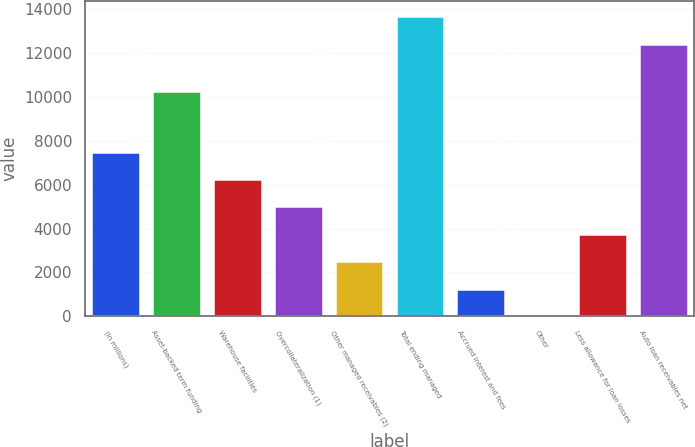Convert chart. <chart><loc_0><loc_0><loc_500><loc_500><bar_chart><fcel>(In millions)<fcel>Asset-backed term funding<fcel>Warehouse facilities<fcel>Overcollateralization (1)<fcel>Other managed receivables (2)<fcel>Total ending managed<fcel>Accrued interest and fees<fcel>Other<fcel>Less allowance for loan losses<fcel>Auto loan receivables net<nl><fcel>7508.88<fcel>10273.4<fcel>6258.55<fcel>5008.22<fcel>2507.56<fcel>13678.8<fcel>1257.23<fcel>6.9<fcel>3757.89<fcel>12428.5<nl></chart> 